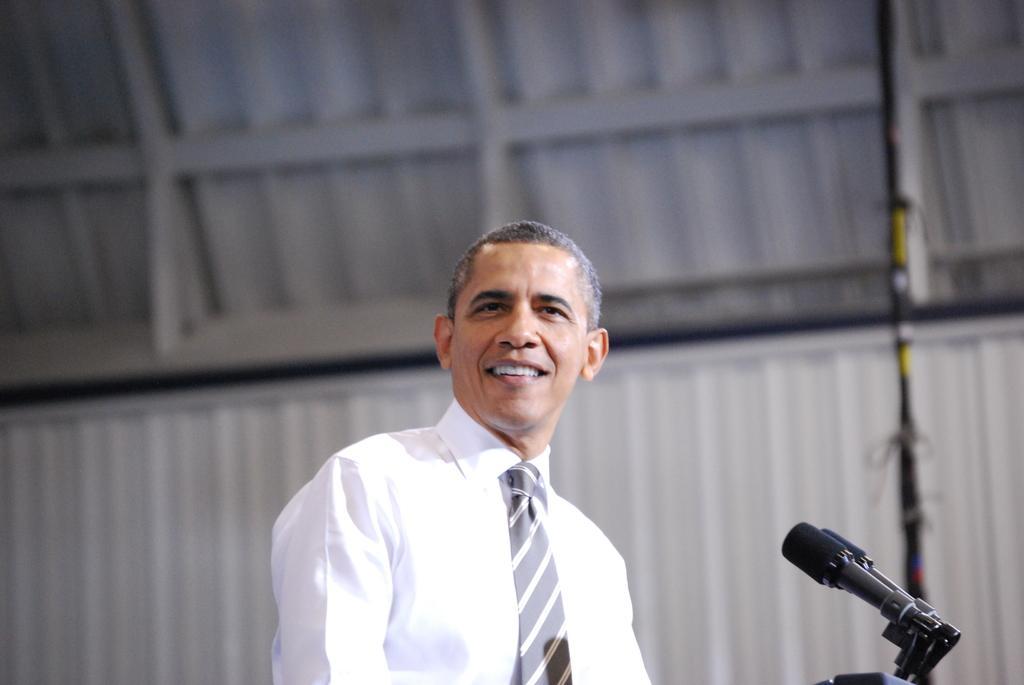Could you give a brief overview of what you see in this image? In the picture I can see a person wearing white color shirt standing, there are microphones on right side of the picture and in the background of the picture there is metal sheet wall. 